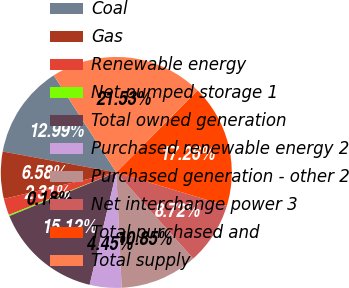<chart> <loc_0><loc_0><loc_500><loc_500><pie_chart><fcel>Coal<fcel>Gas<fcel>Renewable energy<fcel>Net pumped storage 1<fcel>Total owned generation<fcel>Purchased renewable energy 2<fcel>Purchased generation - other 2<fcel>Net interchange power 3<fcel>Total purchased and<fcel>Total supply<nl><fcel>12.99%<fcel>6.58%<fcel>2.31%<fcel>0.18%<fcel>15.12%<fcel>4.45%<fcel>10.85%<fcel>8.72%<fcel>17.26%<fcel>21.53%<nl></chart> 